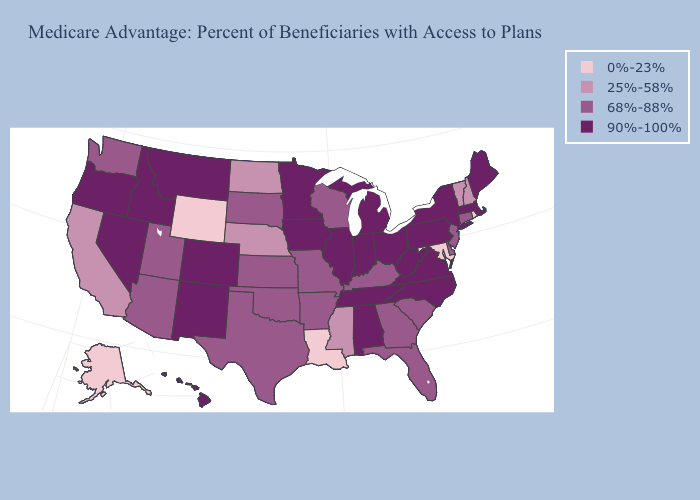Does Washington have the lowest value in the USA?
Give a very brief answer. No. Name the states that have a value in the range 68%-88%?
Quick response, please. Connecticut, Delaware, Florida, Georgia, Kansas, Kentucky, Missouri, New Jersey, Oklahoma, South Carolina, South Dakota, Texas, Utah, Washington, Wisconsin, Arkansas, Arizona. Name the states that have a value in the range 90%-100%?
Quick response, please. Colorado, Hawaii, Iowa, Idaho, Illinois, Indiana, Massachusetts, Maine, Michigan, Minnesota, Montana, North Carolina, New Mexico, Nevada, New York, Ohio, Oregon, Pennsylvania, Tennessee, Virginia, West Virginia, Alabama. What is the value of Arizona?
Give a very brief answer. 68%-88%. Does Mississippi have a lower value than Alaska?
Quick response, please. No. What is the lowest value in states that border West Virginia?
Quick response, please. 0%-23%. Does the map have missing data?
Write a very short answer. No. Among the states that border South Carolina , does North Carolina have the highest value?
Short answer required. Yes. Does the first symbol in the legend represent the smallest category?
Concise answer only. Yes. What is the value of Michigan?
Short answer required. 90%-100%. What is the value of Oklahoma?
Write a very short answer. 68%-88%. Does California have a higher value than Illinois?
Short answer required. No. Name the states that have a value in the range 25%-58%?
Quick response, please. California, Mississippi, North Dakota, Nebraska, New Hampshire, Vermont. Does California have the same value as Montana?
Be succinct. No. Which states have the lowest value in the USA?
Concise answer only. Louisiana, Maryland, Rhode Island, Alaska, Wyoming. 